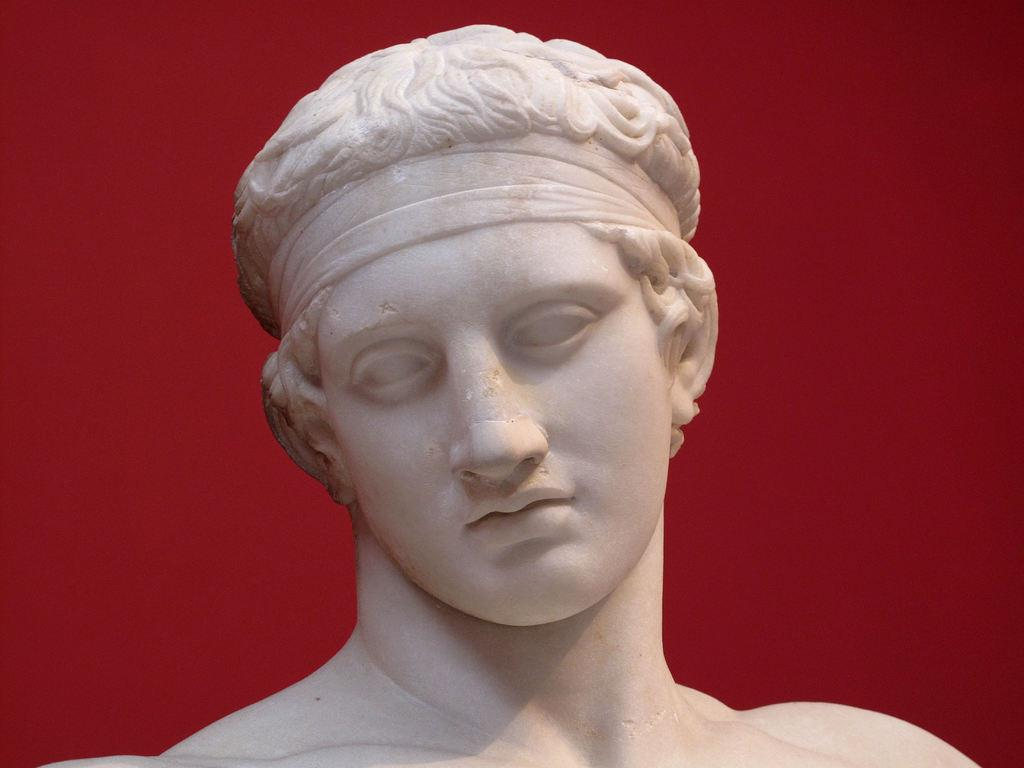What is the main subject in the image? There is a statue in the image. Can you describe any other objects or features in the image? There is a red color object in the background of the image. What type of stick can be seen attracting birds in the image? There is no stick or birds present in the image. What song is being played in the background of the image? There is no mention of any song or audio in the image. 